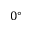Convert formula to latex. <formula><loc_0><loc_0><loc_500><loc_500>0 ^ { \circ }</formula> 